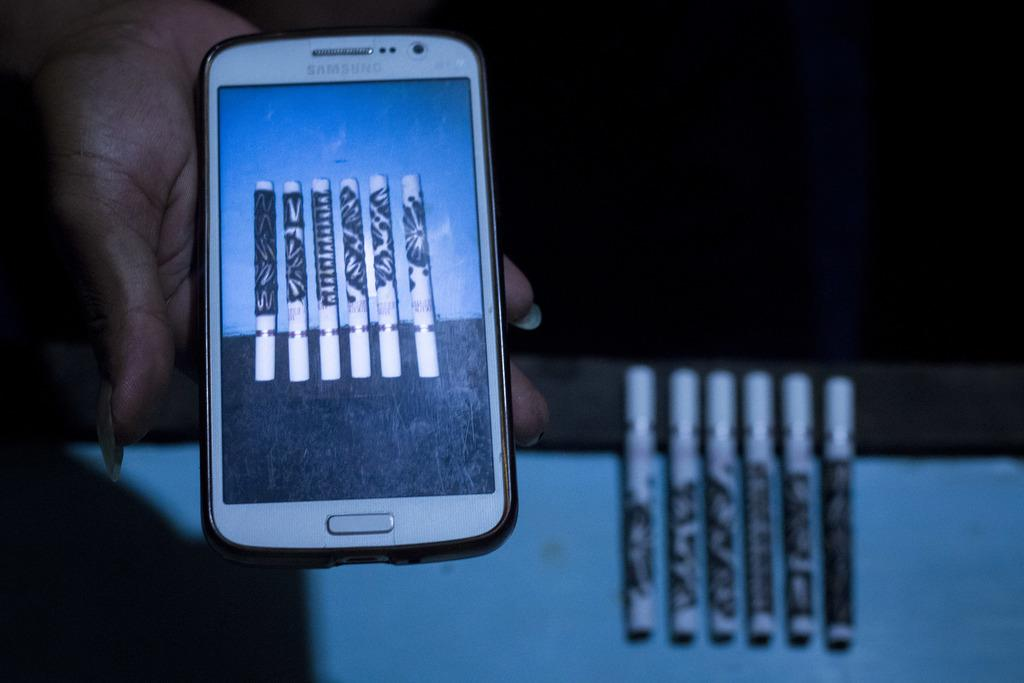<image>
Present a compact description of the photo's key features. a white samsung phone screen with a picture of six rolls on it 